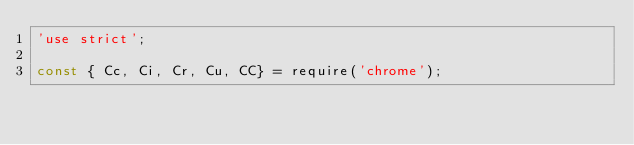<code> <loc_0><loc_0><loc_500><loc_500><_JavaScript_>'use strict';

const { Cc, Ci, Cr, Cu, CC} = require('chrome');</code> 